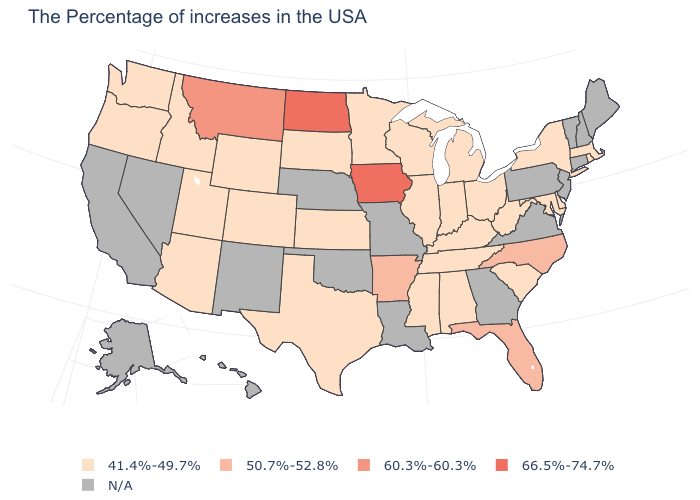What is the lowest value in states that border Texas?
Be succinct. 50.7%-52.8%. Among the states that border Delaware , which have the highest value?
Be succinct. Maryland. What is the value of Michigan?
Keep it brief. 41.4%-49.7%. What is the value of Nebraska?
Concise answer only. N/A. Does the map have missing data?
Short answer required. Yes. Which states have the highest value in the USA?
Write a very short answer. Iowa, North Dakota. What is the value of Oregon?
Keep it brief. 41.4%-49.7%. Name the states that have a value in the range 60.3%-60.3%?
Short answer required. Montana. Does Iowa have the highest value in the USA?
Short answer required. Yes. Which states have the highest value in the USA?
Keep it brief. Iowa, North Dakota. How many symbols are there in the legend?
Be succinct. 5. What is the value of New Jersey?
Concise answer only. N/A. Among the states that border Alabama , which have the highest value?
Short answer required. Florida. Name the states that have a value in the range 60.3%-60.3%?
Quick response, please. Montana. 